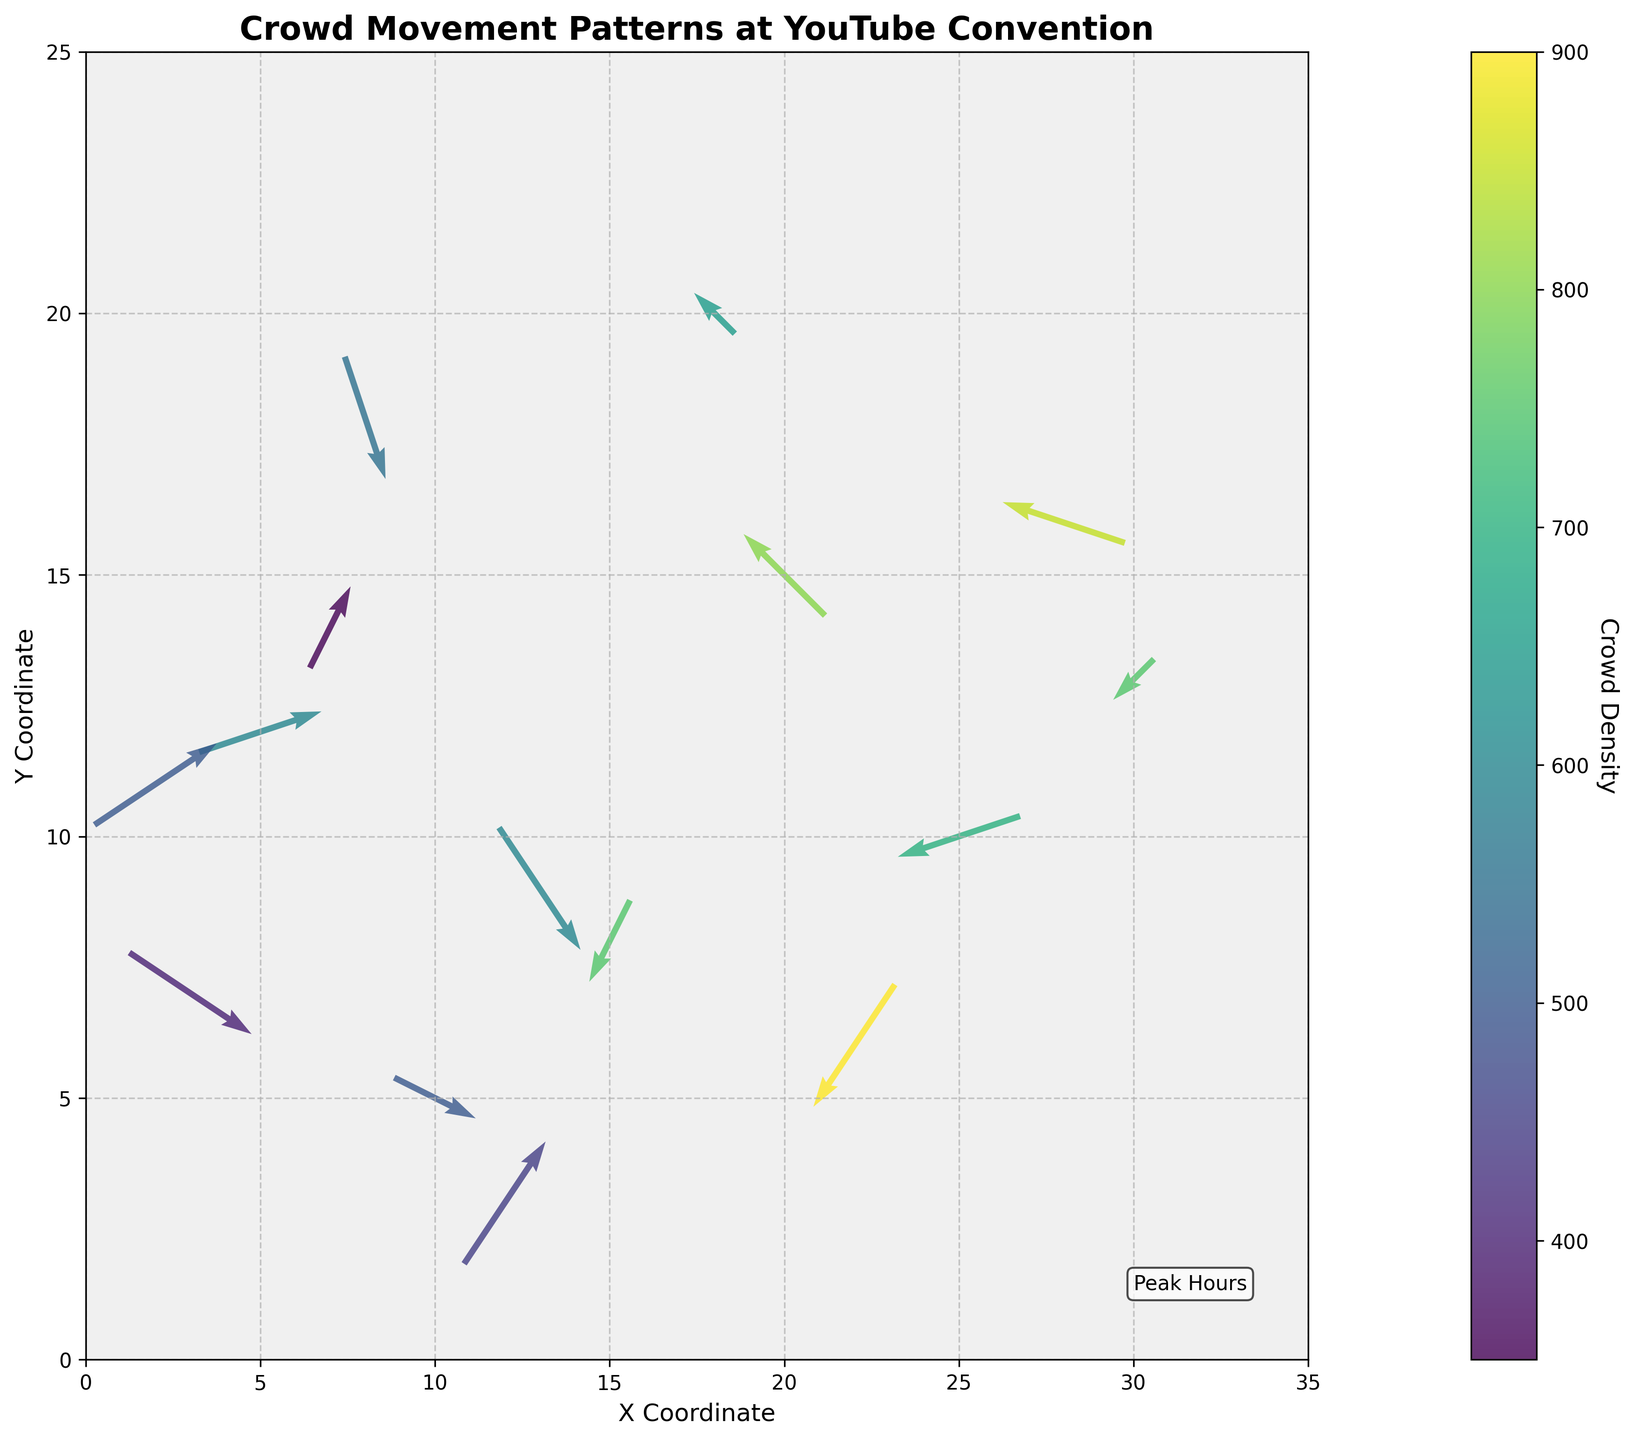How many data points are shown in the quiver plot? By counting the arrows in the quiver plot, we notice there are 15 data points scattered across the plot area.
Answer: 15 What is the title of the quiver plot? The title is displayed at the top of the plot. It reads "Crowd Movement Patterns at YouTube Convention."
Answer: Crowd Movement Patterns at YouTube Convention Describe the color representing the highest crowd density. By checking the color bar, the highest crowd density is indicated by the color corresponding to the highest value in the color range, which appears to be a bright or yellowish-green.
Answer: Yellowish-green Where is the arrow with the largest crowd density located? The color bar and the arrows' colors indicate that the arrow with the largest crowd density (900) is located at coordinates (22, 6).
Answer: (22, 6) What is the approximate scale used for the arrows? The arrow scale is indicated in the plot's quiver settings, showing that the arrows are scaled by approximately 30 units per length.
Answer: 30 units per length Calculate the average value of crowd density for data points where the x coordinate is greater than 10. Data points (x,y,crowd density): (15,8,750), (20,15,800), (25,10,700), (12,3,450), (18,20,650), (22,6,900), (28,16,850), (13,9,600), (30,13,750). Sum = 800+750+700+450+650+900+850+600+750 = 6450. Average = 6450 / 9 = 716.67.
Answer: 716.67 Which area has a significant influx of movement in multiple directions? One example is around the (20, 15) coordinate where the movements show the crowd dispersing in varying directions, indicating a complex movement pattern.
Answer: (20, 15) Identify the main direction of crowd movement in the bottom right quarter of the plot. In the bottom right quarter, arrows around the coordinates (25,10) and (22,6) suggest the dominant movement is towards the south-west direction.
Answer: South-west In which quadrant is the movement most clustered around a single point? The movement most clustered around a single point appears in the lower left quadrant, around the coordinates (10,5).
Answer: Lower left quadrant Compare the crowd density between the arrows at coordinates (5,12) and (7,14). Which one is higher? The arrow at (5,12) has a crowd density of 600, whereas the arrow at (7,14) has a crowd density of 350. Hence, the arrow at (5,12) has a higher crowd density.
Answer: (5,12) 